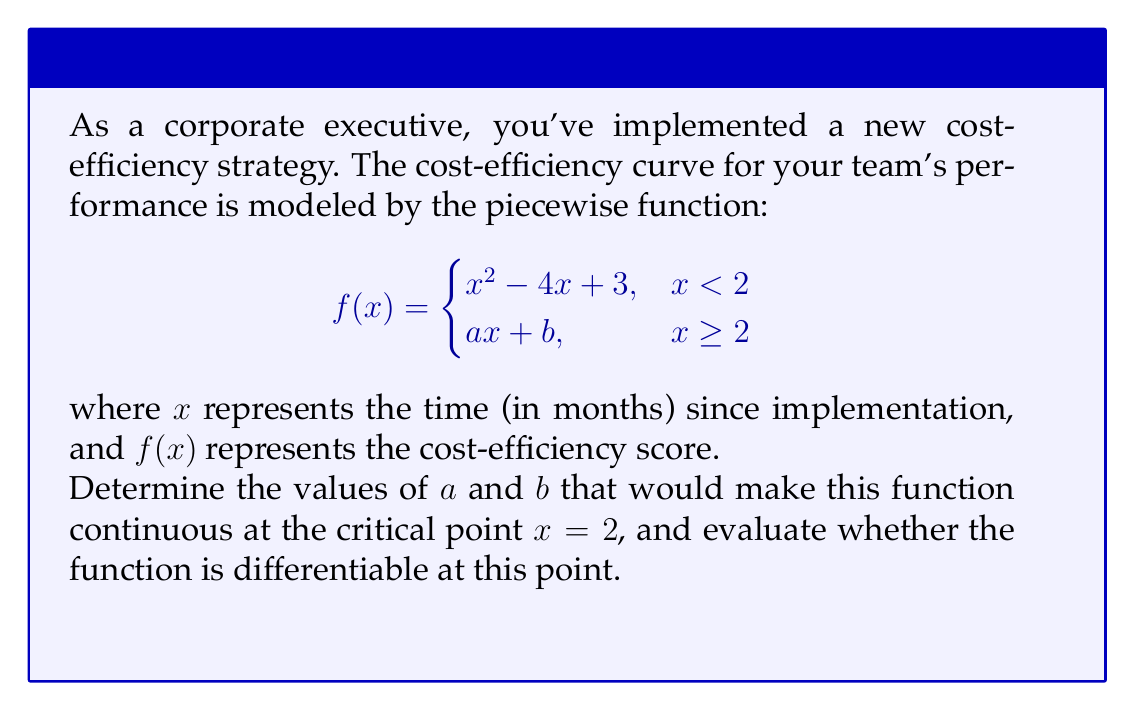Provide a solution to this math problem. Let's approach this step-by-step:

1) For the function to be continuous at $x = 2$, the left-hand limit, right-hand limit, and the function value at $x = 2$ must all be equal.

2) Let's find the left-hand limit:
   $$\lim_{x \to 2^-} f(x) = \lim_{x \to 2^-} (x^2 - 4x + 3) = 2^2 - 4(2) + 3 = 3$$

3) For continuity, we need:
   $$\lim_{x \to 2^+} f(x) = \lim_{x \to 2^-} f(x) = f(2) = 3$$

4) This means:
   $$a(2) + b = 3$$
   $$2a + b = 3 \quad \text{(Equation 1)}$$

5) For the function to be continuous, we also need:
   $$\lim_{x \to 2^+} f(x) = \lim_{x \to 2^+} (ax + b) = a(2) + b = 3$$

   This is the same as Equation 1, so we need one more condition to find $a$ and $b$.

6) For the function to be differentiable at $x = 2$, the left-hand and right-hand derivatives must be equal:

   Left-hand derivative: 
   $$\lim_{x \to 2^-} f'(x) = \lim_{x \to 2^-} (2x - 4) = 2(2) - 4 = 0$$

   Right-hand derivative:
   $$\lim_{x \to 2^+} f'(x) = a$$

7) For differentiability, we need:
   $$a = 0 \quad \text{(Equation 2)}$$

8) Solving Equations 1 and 2:
   $$a = 0$$
   $$b = 3$$

9) Therefore, the continuous and differentiable function is:

   $$f(x) = \begin{cases}
   x^2 - 4x + 3, & x < 2 \\
   3, & x \geq 2
   \end{cases}$$
Answer: $a = 0$, $b = 3$; The function is continuous and differentiable at $x = 2$. 